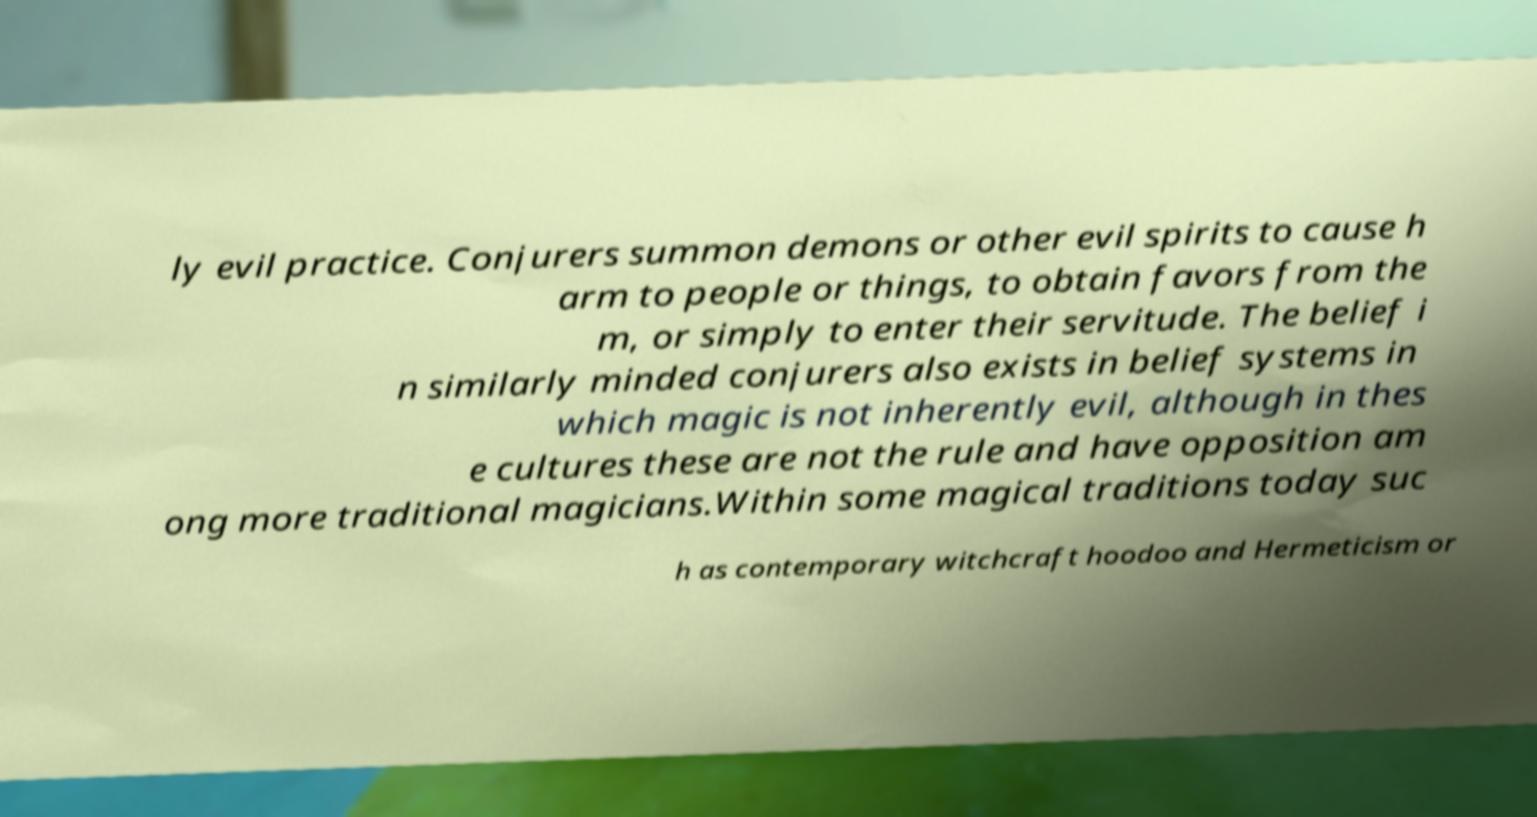Please identify and transcribe the text found in this image. ly evil practice. Conjurers summon demons or other evil spirits to cause h arm to people or things, to obtain favors from the m, or simply to enter their servitude. The belief i n similarly minded conjurers also exists in belief systems in which magic is not inherently evil, although in thes e cultures these are not the rule and have opposition am ong more traditional magicians.Within some magical traditions today suc h as contemporary witchcraft hoodoo and Hermeticism or 